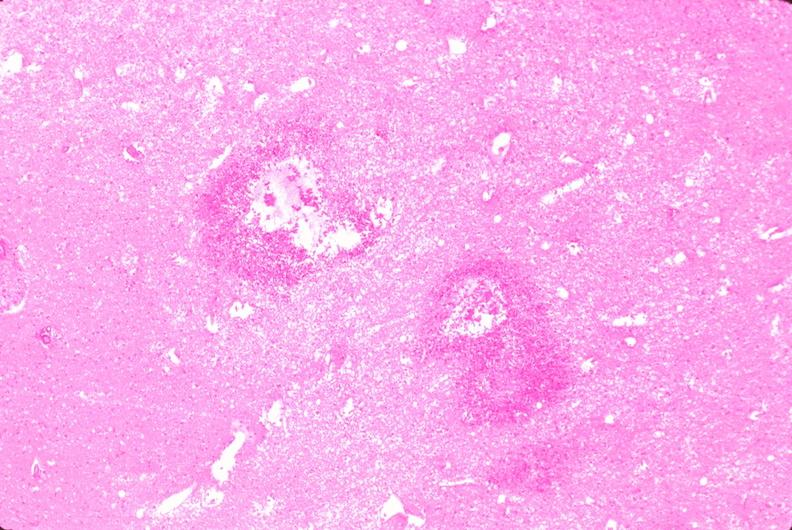why does this image show brain, infarct?
Answer the question using a single word or phrase. Due to ruptured saccular aneurysm and thrombosis of right middle cerebral artery 